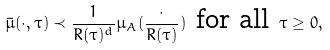Convert formula to latex. <formula><loc_0><loc_0><loc_500><loc_500>\bar { \mu } ( \cdot , \tau ) \prec \frac { 1 } { R ( \tau ) ^ { d } } \mu _ { A } ( \frac { \cdot } { R ( \tau ) } ) \text { for all } \tau \geq 0 ,</formula> 